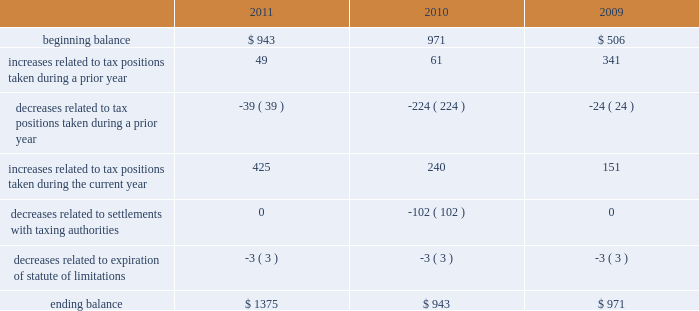As of september 24 , 2011 , the total amount of gross unrecognized tax benefits was $ 1.4 billion , of which $ 563 million , if recognized , would affect the company 2019s effective tax rate .
As of september 25 , 2010 , the total amount of gross unrecognized tax benefits was $ 943 million , of which $ 404 million , if recognized , would affect the company 2019s effective tax rate .
The aggregate changes in the balance of gross unrecognized tax benefits , which excludes interest and penalties , for the three years ended september 24 , 2011 , is as follows ( in millions ) : .
The company includes interest and penalties related to unrecognized tax benefits within the provision for income taxes .
As of september 24 , 2011 and september 25 , 2010 , the total amount of gross interest and penalties accrued was $ 261 million and $ 247 million , respectively , which is classified as non-current liabilities in the consolidated balance sheets .
In connection with tax matters , the company recognized interest expense in 2011 and 2009 of $ 14 million and $ 64 million , respectively , and in 2010 the company recognized an interest benefit of $ 43 million .
The company is subject to taxation and files income tax returns in the u.s .
Federal jurisdiction and in many state and foreign jurisdictions .
For u.s .
Federal income tax purposes , all years prior to 2004 are closed .
The internal revenue service ( the 201cirs 201d ) has completed its field audit of the company 2019s federal income tax returns for the years 2004 through 2006 and proposed certain adjustments .
The company has contested certain of these adjustments through the irs appeals office .
The irs is currently examining the years 2007 through 2009 .
In addition , the company is also subject to audits by state , local and foreign tax authorities .
In major states and major foreign jurisdictions , the years subsequent to 1988 and 2001 , respectively , generally remain open and could be subject to examination by the taxing authorities .
Management believes that an adequate provision has been made for any adjustments that may result from tax examinations .
However , the outcome of tax audits cannot be predicted with certainty .
If any issues addressed in the company 2019s tax audits are resolved in a manner not consistent with management 2019s expectations , the company could be required to adjust its provision for income tax in the period such resolution occurs .
Although timing of the resolution and/or closure of audits is not certain , the company does not believe it is reasonably possible that its unrecognized tax benefits would materially change in the next 12 months .
Note 6 2013 shareholders 2019 equity and share-based compensation preferred stock the company has five million shares of authorized preferred stock , none of which is issued or outstanding .
Under the terms of the company 2019s restated articles of incorporation , the board of directors is authorized to determine or alter the rights , preferences , privileges and restrictions of the company 2019s authorized but unissued shares of preferred stock .
Comprehensive income comprehensive income consists of two components , net income and other comprehensive income .
Other comprehensive income refers to revenue , expenses , gains and losses that under gaap are recorded as an element .
What was the net change in millions of the gross unrecognized tax benefits between 2009 and 2010? 
Computations: (943 - 971)
Answer: -28.0. 